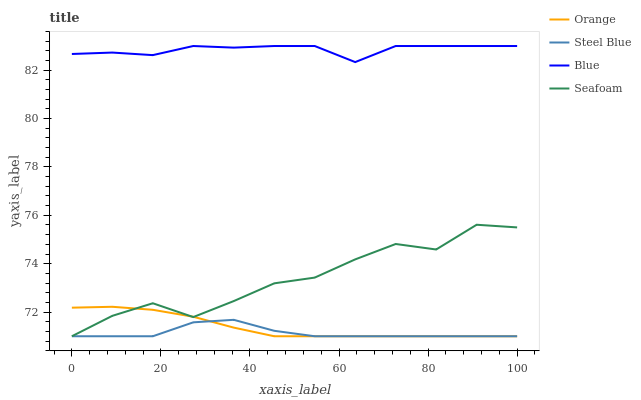Does Steel Blue have the minimum area under the curve?
Answer yes or no. Yes. Does Blue have the maximum area under the curve?
Answer yes or no. Yes. Does Blue have the minimum area under the curve?
Answer yes or no. No. Does Steel Blue have the maximum area under the curve?
Answer yes or no. No. Is Orange the smoothest?
Answer yes or no. Yes. Is Seafoam the roughest?
Answer yes or no. Yes. Is Blue the smoothest?
Answer yes or no. No. Is Blue the roughest?
Answer yes or no. No. Does Orange have the lowest value?
Answer yes or no. Yes. Does Blue have the lowest value?
Answer yes or no. No. Does Blue have the highest value?
Answer yes or no. Yes. Does Steel Blue have the highest value?
Answer yes or no. No. Is Seafoam less than Blue?
Answer yes or no. Yes. Is Blue greater than Steel Blue?
Answer yes or no. Yes. Does Seafoam intersect Orange?
Answer yes or no. Yes. Is Seafoam less than Orange?
Answer yes or no. No. Is Seafoam greater than Orange?
Answer yes or no. No. Does Seafoam intersect Blue?
Answer yes or no. No. 